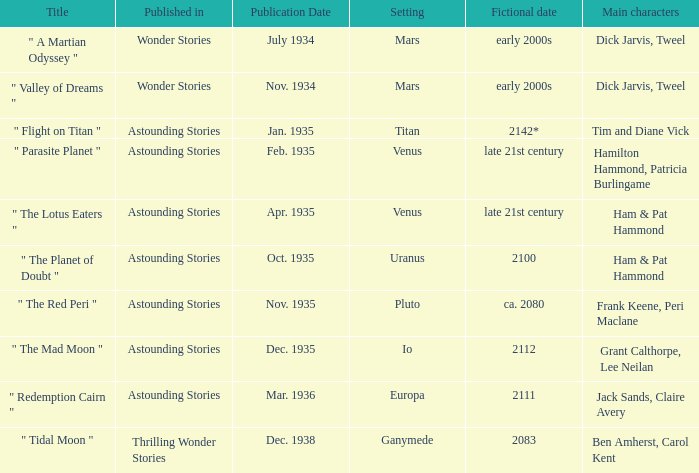Name the title when the main characters are grant calthorpe, lee neilan and the published in of astounding stories " The Mad Moon ". 